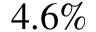Convert formula to latex. <formula><loc_0><loc_0><loc_500><loc_500>4 . 6 \%</formula> 